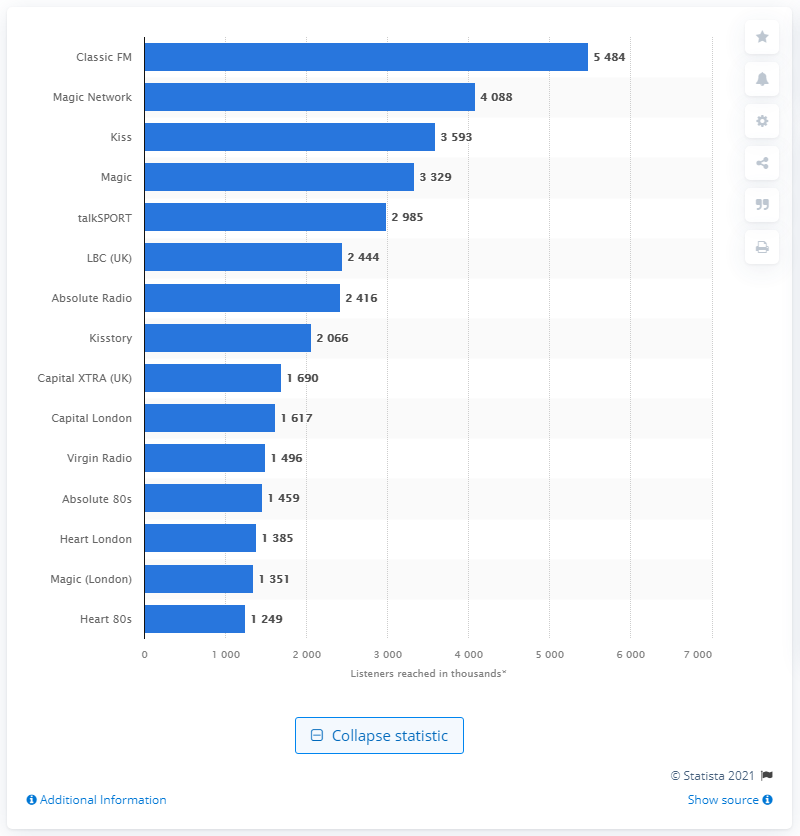Identify some key points in this picture. Classic FM features a contemporary station that is accompanied by the magic of music. 